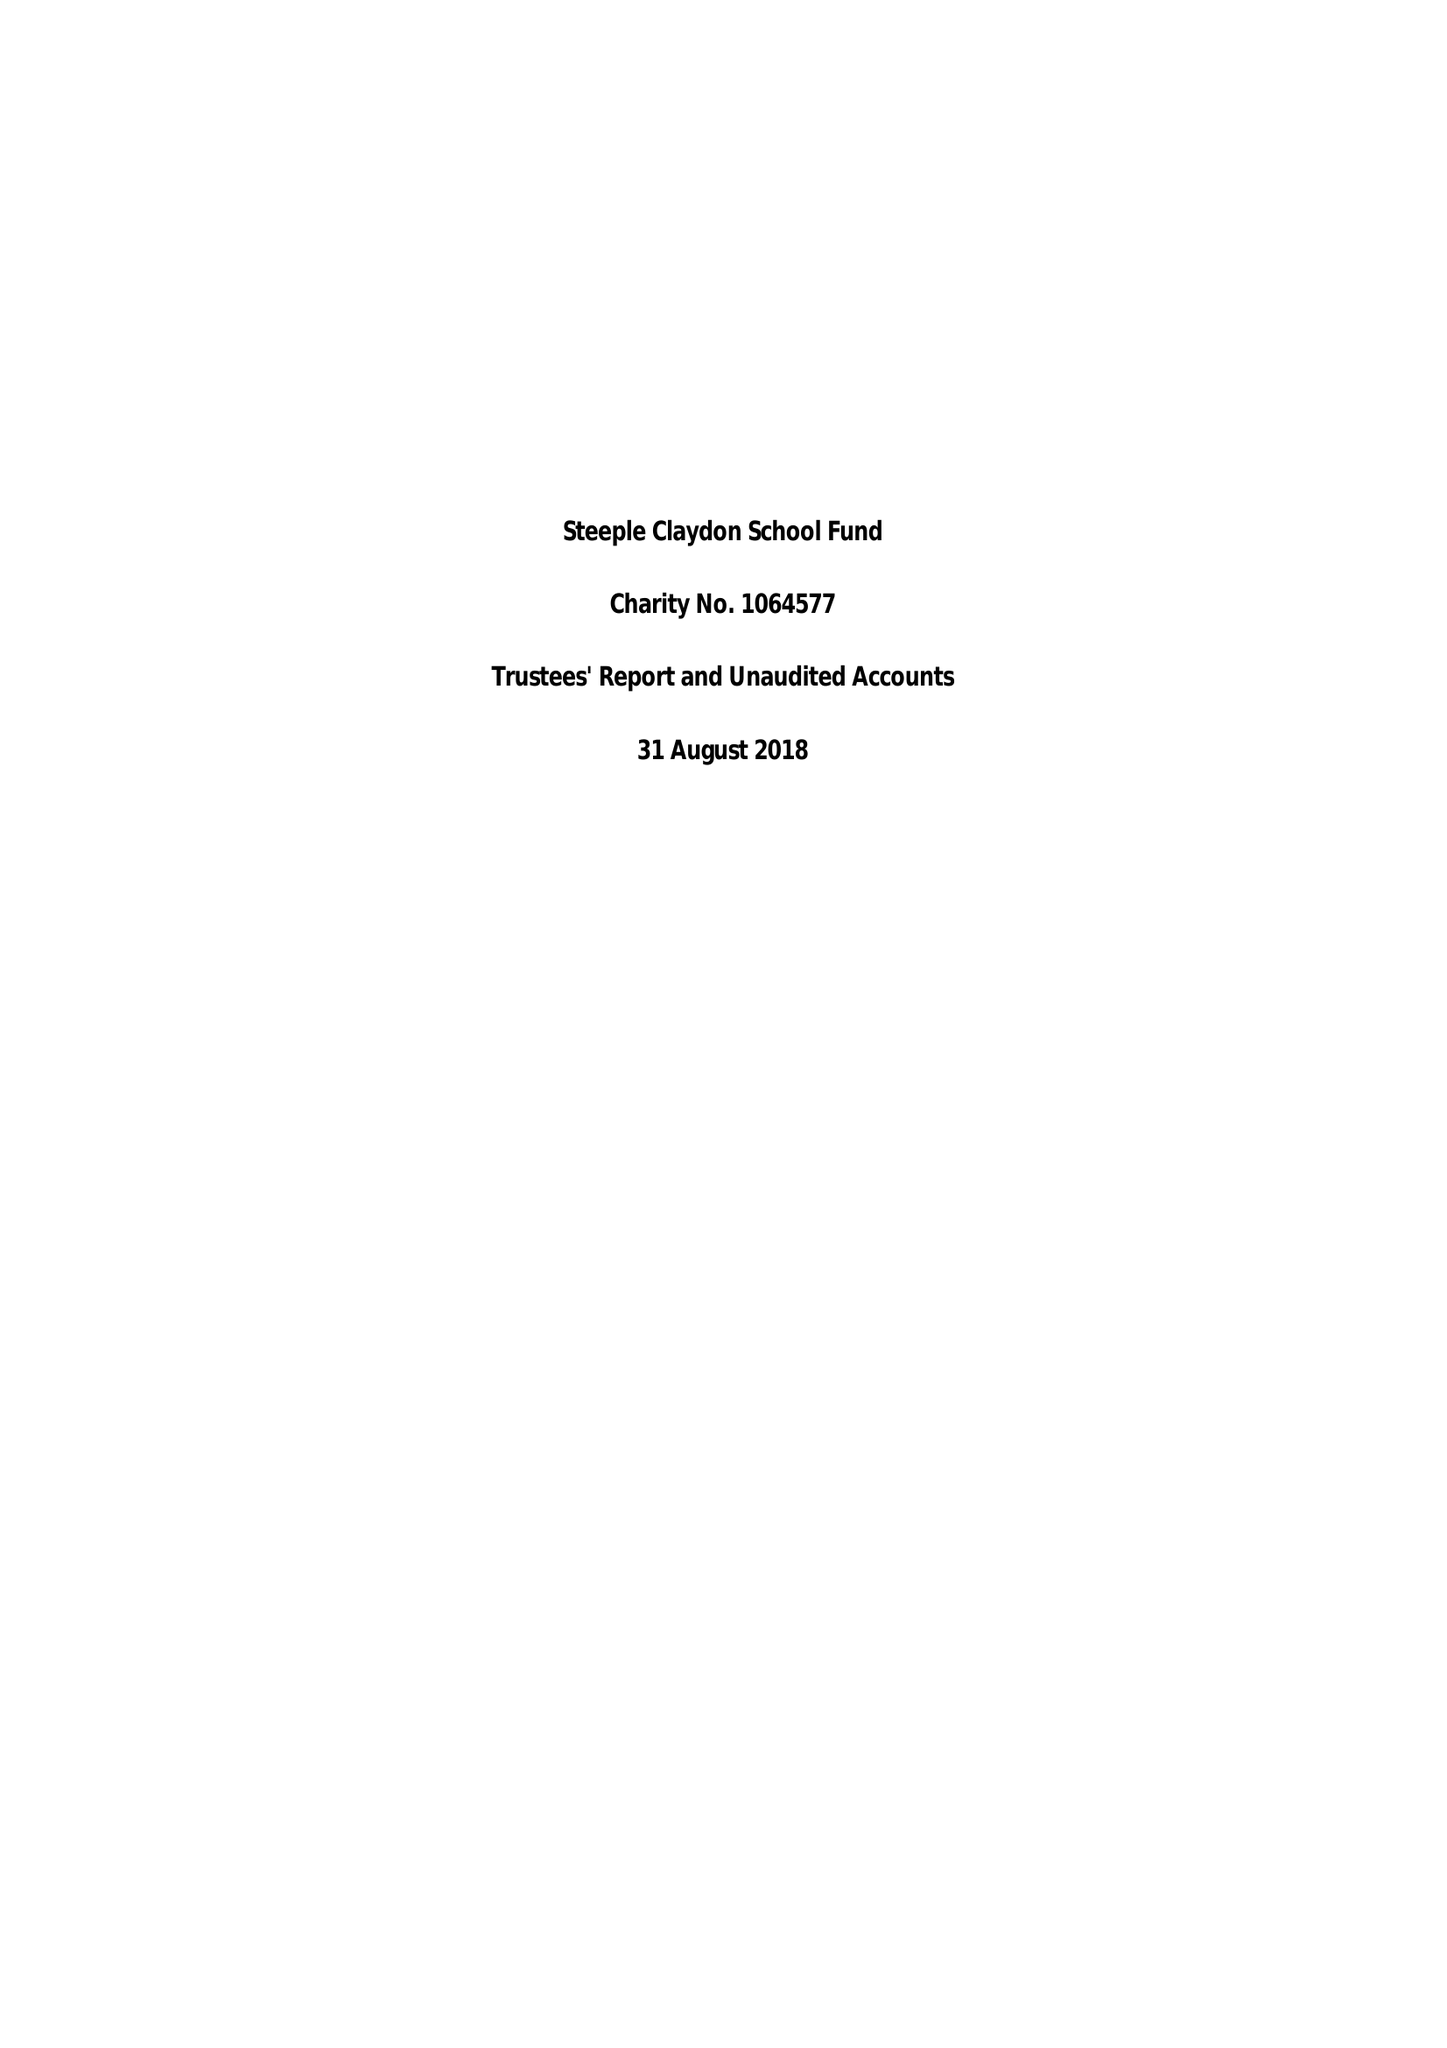What is the value for the charity_name?
Answer the question using a single word or phrase. Steeple Claydon School Fund 